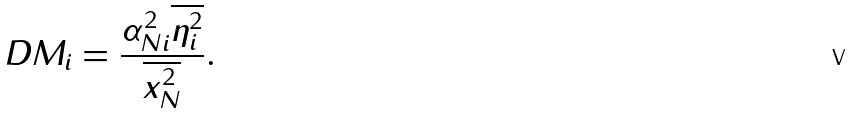Convert formula to latex. <formula><loc_0><loc_0><loc_500><loc_500>D M _ { i } = \frac { \alpha _ { N i } ^ { 2 } \overline { \eta _ { i } ^ { 2 } } } { \overline { x _ { N } ^ { 2 } } } .</formula> 